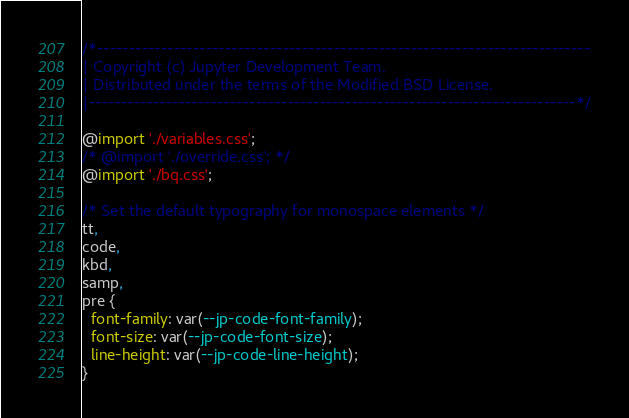<code> <loc_0><loc_0><loc_500><loc_500><_CSS_>/*-----------------------------------------------------------------------------
| Copyright (c) Jupyter Development Team.
| Distributed under the terms of the Modified BSD License.
|----------------------------------------------------------------------------*/

@import './variables.css';
/* @import './override.css'; */
@import './bq.css';

/* Set the default typography for monospace elements */
tt,
code,
kbd,
samp,
pre {
  font-family: var(--jp-code-font-family);
  font-size: var(--jp-code-font-size);
  line-height: var(--jp-code-line-height);
}
</code> 